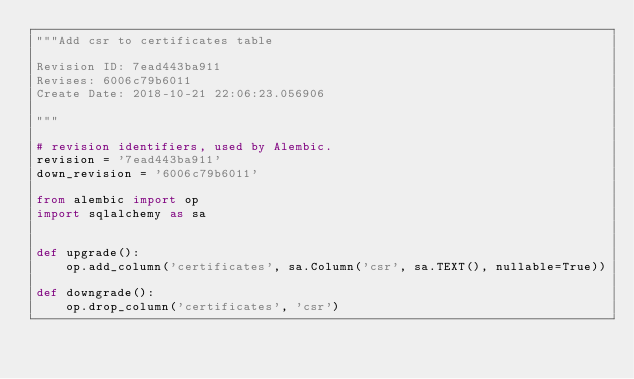Convert code to text. <code><loc_0><loc_0><loc_500><loc_500><_Python_>"""Add csr to certificates table

Revision ID: 7ead443ba911
Revises: 6006c79b6011
Create Date: 2018-10-21 22:06:23.056906

"""

# revision identifiers, used by Alembic.
revision = '7ead443ba911'
down_revision = '6006c79b6011'

from alembic import op
import sqlalchemy as sa


def upgrade():
    op.add_column('certificates', sa.Column('csr', sa.TEXT(), nullable=True))

def downgrade():
    op.drop_column('certificates', 'csr')
</code> 